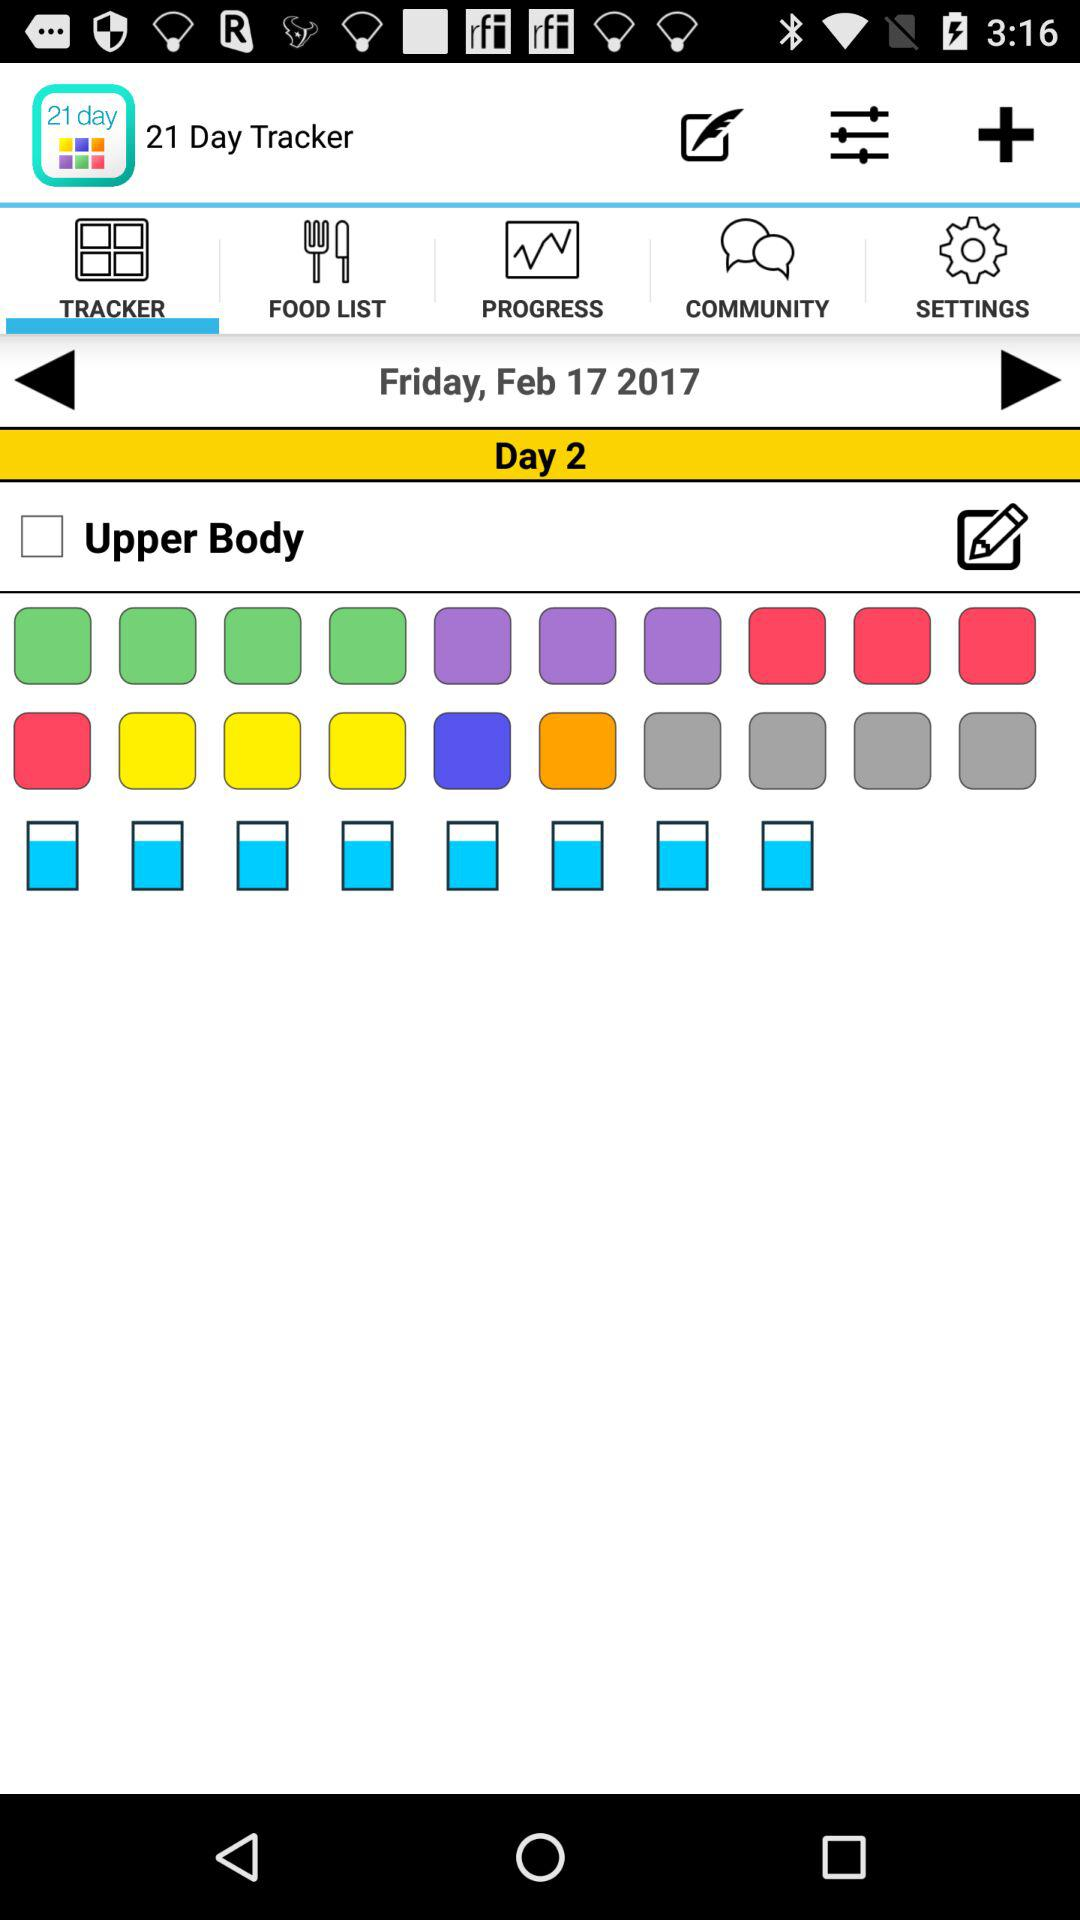What option is unchecked? The unchecked option is "Upper Body". 